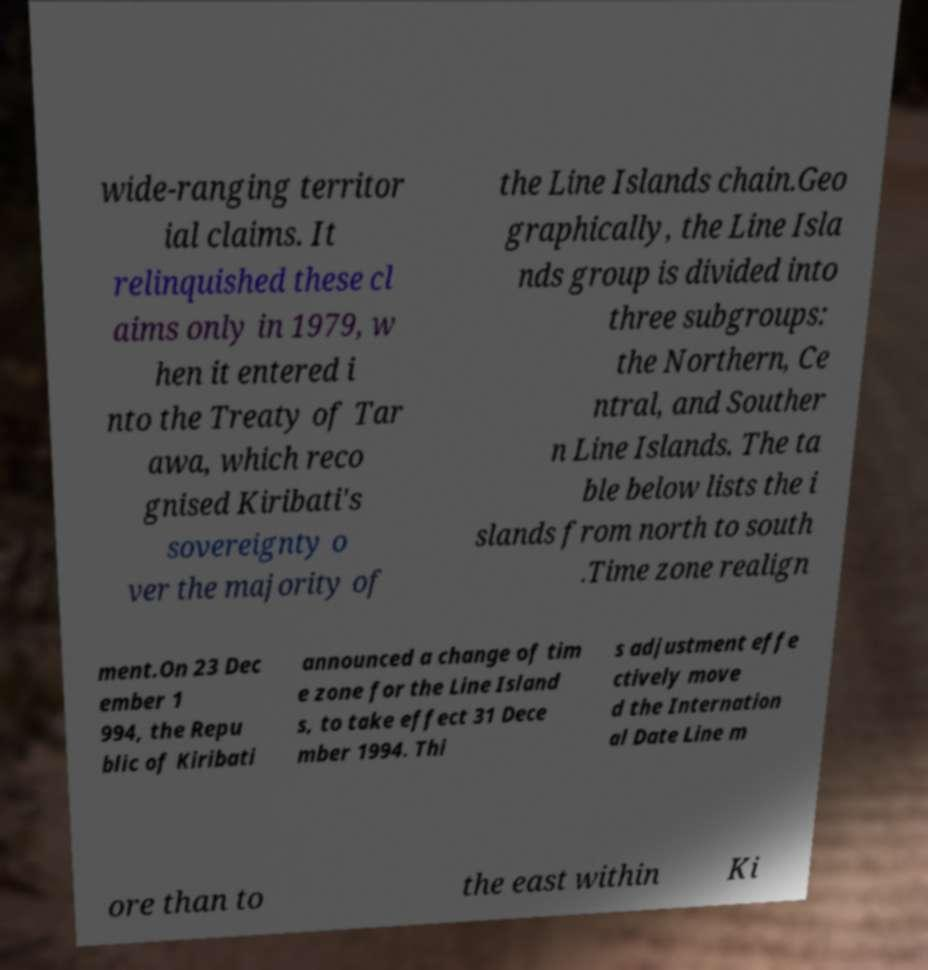I need the written content from this picture converted into text. Can you do that? wide-ranging territor ial claims. It relinquished these cl aims only in 1979, w hen it entered i nto the Treaty of Tar awa, which reco gnised Kiribati's sovereignty o ver the majority of the Line Islands chain.Geo graphically, the Line Isla nds group is divided into three subgroups: the Northern, Ce ntral, and Souther n Line Islands. The ta ble below lists the i slands from north to south .Time zone realign ment.On 23 Dec ember 1 994, the Repu blic of Kiribati announced a change of tim e zone for the Line Island s, to take effect 31 Dece mber 1994. Thi s adjustment effe ctively move d the Internation al Date Line m ore than to the east within Ki 